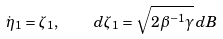<formula> <loc_0><loc_0><loc_500><loc_500>\dot { \eta } _ { 1 } = \zeta _ { 1 } , \quad d \zeta _ { 1 } = \sqrt { 2 \beta ^ { - 1 } \gamma } \, d B</formula> 